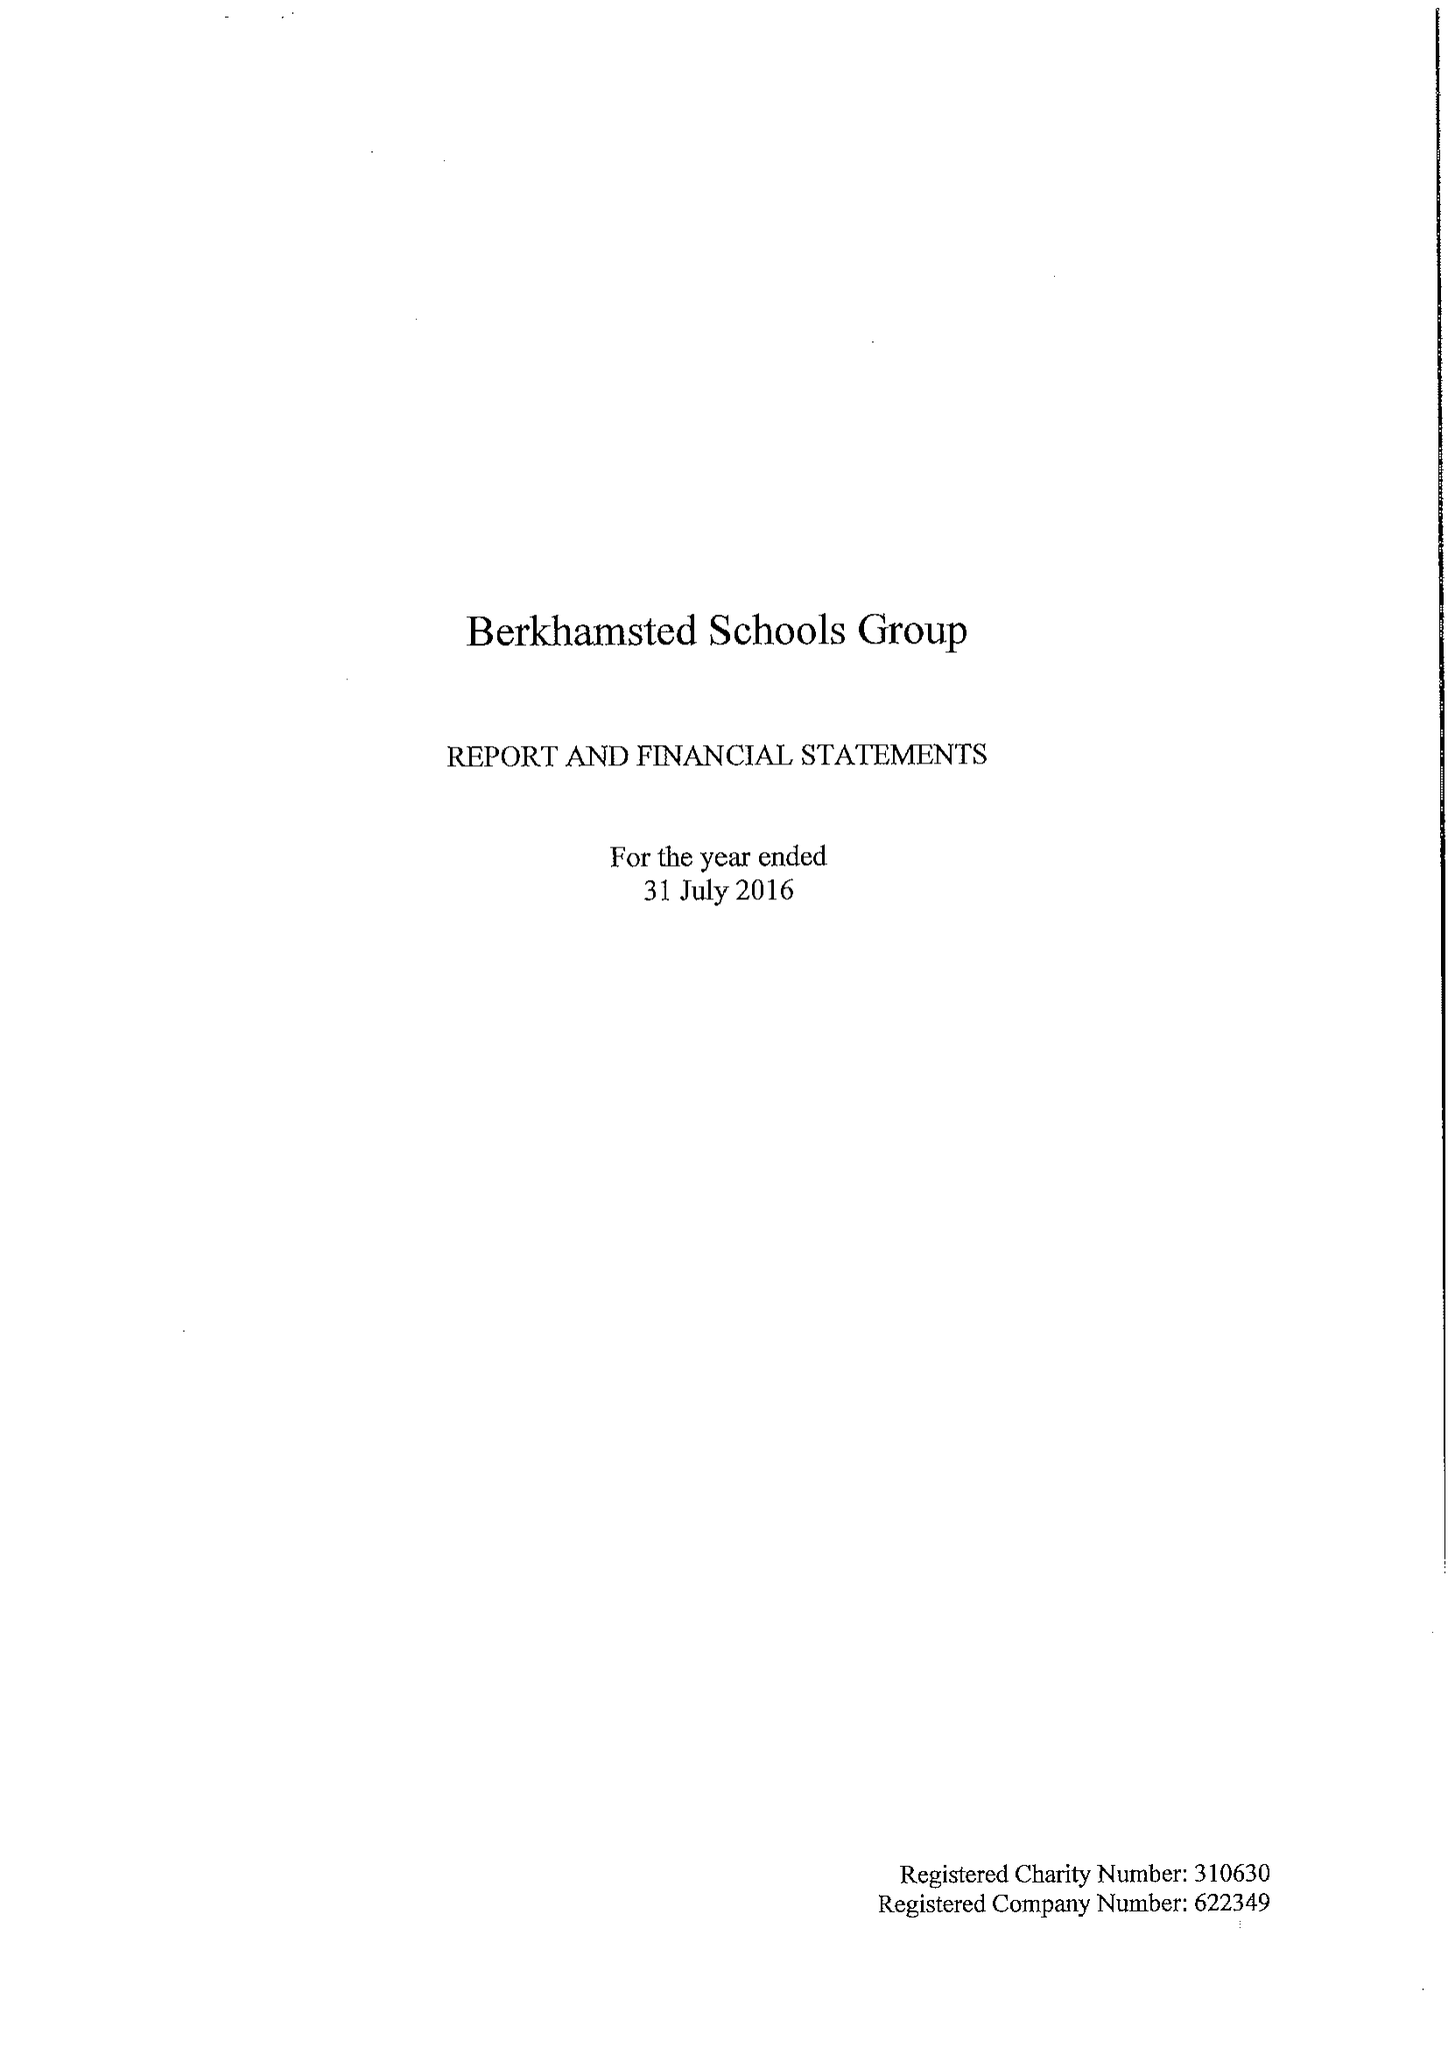What is the value for the address__street_line?
Answer the question using a single word or phrase. 6 CHESHAM ROAD 